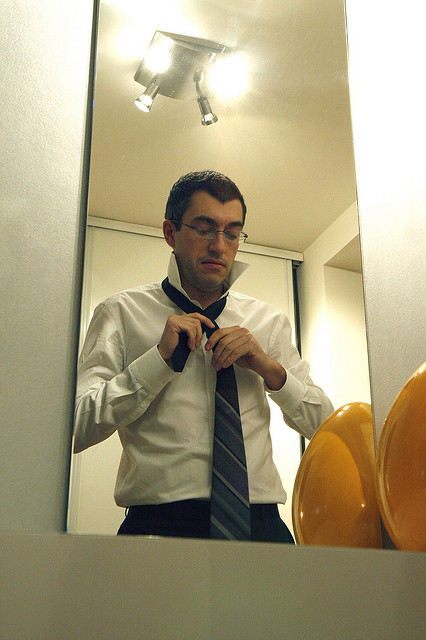Could you explain the positioning of the lightbulbs? The lightbulbs are strategically positioned above the man and around the mirror. Their arrangement is designed to cast an even light across the area, ensuring the man has ample illumination as he adjusts his necktie. This setup is common in personal grooming spaces where proper lighting is essential. 